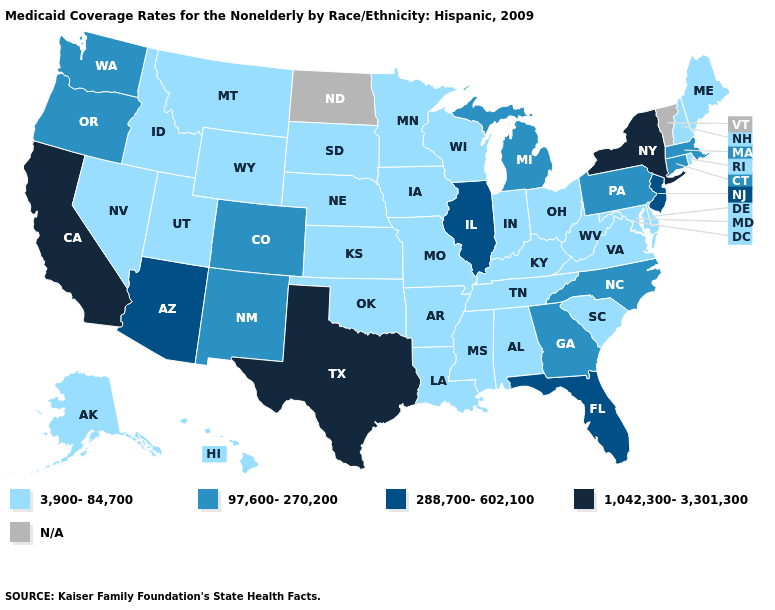Does the map have missing data?
Write a very short answer. Yes. Does the map have missing data?
Concise answer only. Yes. Among the states that border Arkansas , does Missouri have the highest value?
Short answer required. No. Name the states that have a value in the range 1,042,300-3,301,300?
Keep it brief. California, New York, Texas. What is the value of Maine?
Give a very brief answer. 3,900-84,700. Name the states that have a value in the range 97,600-270,200?
Answer briefly. Colorado, Connecticut, Georgia, Massachusetts, Michigan, New Mexico, North Carolina, Oregon, Pennsylvania, Washington. Which states have the highest value in the USA?
Quick response, please. California, New York, Texas. What is the value of New York?
Quick response, please. 1,042,300-3,301,300. What is the value of Arizona?
Answer briefly. 288,700-602,100. Name the states that have a value in the range 97,600-270,200?
Concise answer only. Colorado, Connecticut, Georgia, Massachusetts, Michigan, New Mexico, North Carolina, Oregon, Pennsylvania, Washington. Among the states that border Pennsylvania , which have the highest value?
Write a very short answer. New York. What is the highest value in the USA?
Keep it brief. 1,042,300-3,301,300. Does Arkansas have the lowest value in the South?
Keep it brief. Yes. 